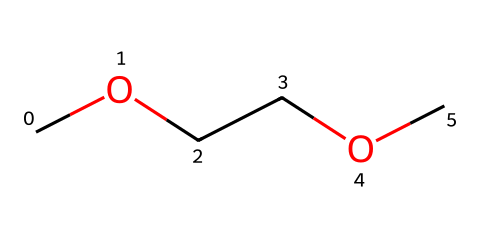What is the name of this chemical? The provided SMILES representation corresponds to a chemical known as dimethoxyethane. This can be identified based on the 'COCC' portion indicating two methoxy (-OCH3) groups and an ethane backbone.
Answer: dimethoxyethane How many carbon atoms are present in dimethoxyethane? In the SMILES COCCOC, there are a total of 4 carbon atoms. We can count them directly from the structure, where each 'C' represents a carbon atom.
Answer: 4 What type of chemical bond predominantly exists in ethers like dimethoxyethane? Ethers, including dimethoxyethane, predominantly contain ether linkages characterized by a single bond between oxygen and two alkyl groups (R-O-R'). This is observed in the molecular structure developed from the given SMILES.
Answer: single bond How many oxygen atoms are in dimethoxyethane? By analyzing the SMILES structure COCCOC, we notice there are two 'O' characters, indicating two oxygen atoms are present in the molecule.
Answer: 2 What is the functional group of dimethoxyethane? The functional group present in dimethoxyethane is an ether. This is inferred from the arrangement of the carbon and oxygen atoms, specifically the -O- linkage between carbon chains.
Answer: ether What is the molecular formula of dimethoxyethane? The molecular formula can be derived from the counts of each type of atom present in the SMILES representation. It contains 4 carbon (C), 10 hydrogen (H), and 2 oxygen (O) atoms, leading to the formula C4H10O2.
Answer: C4H10O2 Does dimethoxyethane have a linear or branched structure? Given its structure from the SMILES, dimethoxyethane has a linear structure due to the continuous chain of carbon atoms without any branching. This can be visualized based on the arrangement of the carbon atoms in the chemical.
Answer: linear 